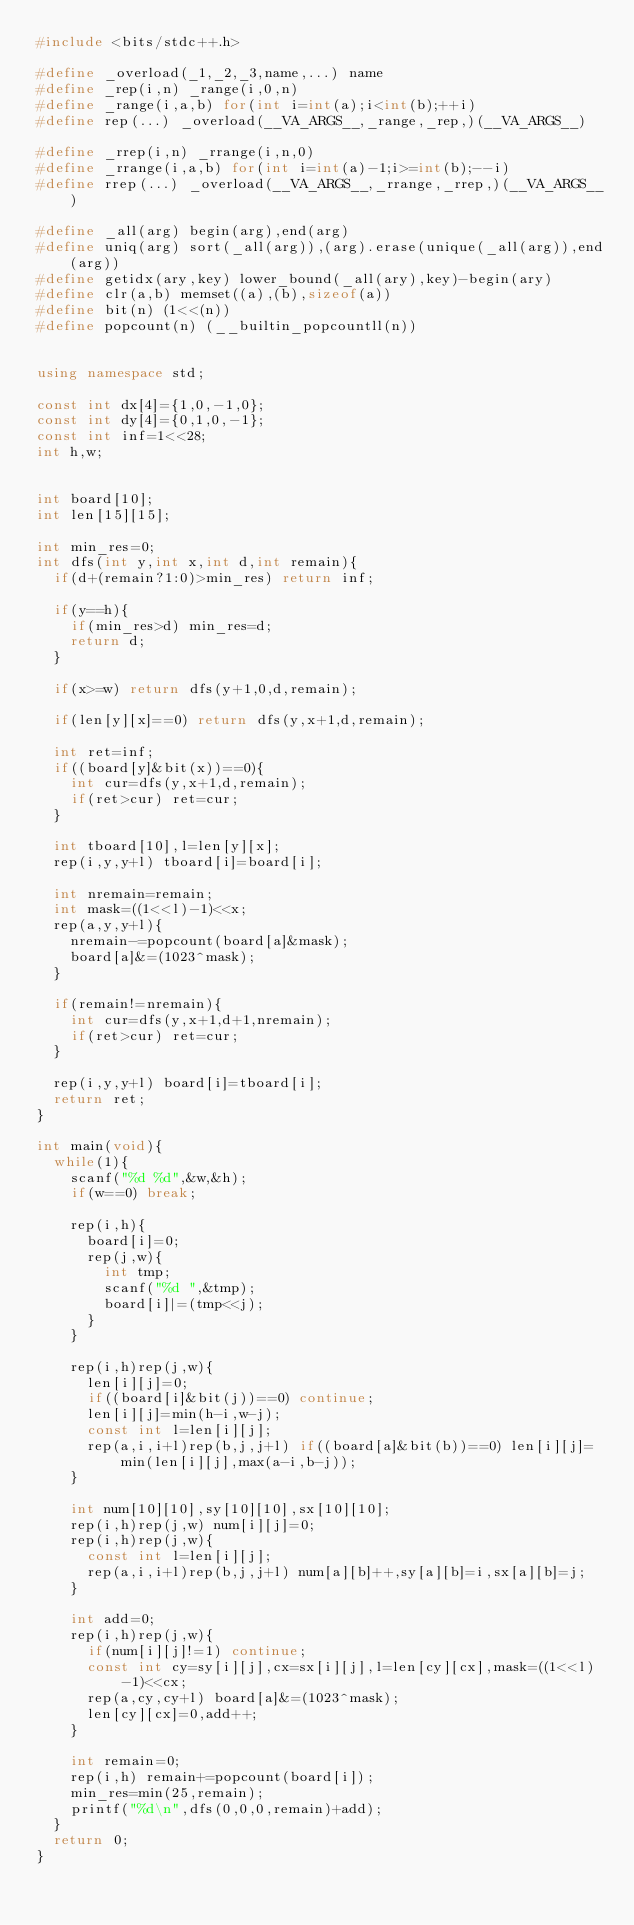Convert code to text. <code><loc_0><loc_0><loc_500><loc_500><_C++_>#include <bits/stdc++.h>

#define _overload(_1,_2,_3,name,...) name
#define _rep(i,n) _range(i,0,n)
#define _range(i,a,b) for(int i=int(a);i<int(b);++i)
#define rep(...) _overload(__VA_ARGS__,_range,_rep,)(__VA_ARGS__)

#define _rrep(i,n) _rrange(i,n,0)
#define _rrange(i,a,b) for(int i=int(a)-1;i>=int(b);--i)
#define rrep(...) _overload(__VA_ARGS__,_rrange,_rrep,)(__VA_ARGS__)

#define _all(arg) begin(arg),end(arg)
#define uniq(arg) sort(_all(arg)),(arg).erase(unique(_all(arg)),end(arg))
#define getidx(ary,key) lower_bound(_all(ary),key)-begin(ary)
#define clr(a,b) memset((a),(b),sizeof(a))
#define bit(n) (1<<(n))
#define popcount(n) (__builtin_popcountll(n))


using namespace std;

const int dx[4]={1,0,-1,0};
const int dy[4]={0,1,0,-1};
const int inf=1<<28;
int h,w;


int board[10];
int len[15][15];

int min_res=0;
int dfs(int y,int x,int d,int remain){
	if(d+(remain?1:0)>min_res) return inf;

	if(y==h){		
		if(min_res>d) min_res=d;
		return d;
	}

	if(x>=w) return dfs(y+1,0,d,remain);
	
	if(len[y][x]==0) return dfs(y,x+1,d,remain);

	int ret=inf;
	if((board[y]&bit(x))==0){
		int cur=dfs(y,x+1,d,remain);
		if(ret>cur) ret=cur;
	}

	int tboard[10],l=len[y][x];
	rep(i,y,y+l) tboard[i]=board[i];

	int nremain=remain;
	int mask=((1<<l)-1)<<x;
	rep(a,y,y+l){
		nremain-=popcount(board[a]&mask);
		board[a]&=(1023^mask);
	}

	if(remain!=nremain){
		int cur=dfs(y,x+1,d+1,nremain);
		if(ret>cur) ret=cur;
	}
	
	rep(i,y,y+l) board[i]=tboard[i];
	return ret;
}

int main(void){
	while(1){
		scanf("%d %d",&w,&h);
		if(w==0) break;

		rep(i,h){
			board[i]=0;
			rep(j,w){
				int tmp;
				scanf("%d ",&tmp);
				board[i]|=(tmp<<j);
			}
		}

		rep(i,h)rep(j,w){
			len[i][j]=0;
			if((board[i]&bit(j))==0) continue;
			len[i][j]=min(h-i,w-j);
			const int l=len[i][j];
			rep(a,i,i+l)rep(b,j,j+l) if((board[a]&bit(b))==0) len[i][j]=min(len[i][j],max(a-i,b-j));
		}

		int num[10][10],sy[10][10],sx[10][10];
		rep(i,h)rep(j,w) num[i][j]=0;
		rep(i,h)rep(j,w){
			const int l=len[i][j];
			rep(a,i,i+l)rep(b,j,j+l) num[a][b]++,sy[a][b]=i,sx[a][b]=j;
		}

		int add=0;
		rep(i,h)rep(j,w){
			if(num[i][j]!=1) continue;
			const int cy=sy[i][j],cx=sx[i][j],l=len[cy][cx],mask=((1<<l)-1)<<cx;
			rep(a,cy,cy+l) board[a]&=(1023^mask);
			len[cy][cx]=0,add++;
		}

		int remain=0;
		rep(i,h) remain+=popcount(board[i]);
		min_res=min(25,remain);
		printf("%d\n",dfs(0,0,0,remain)+add);
	}
	return 0;
}</code> 